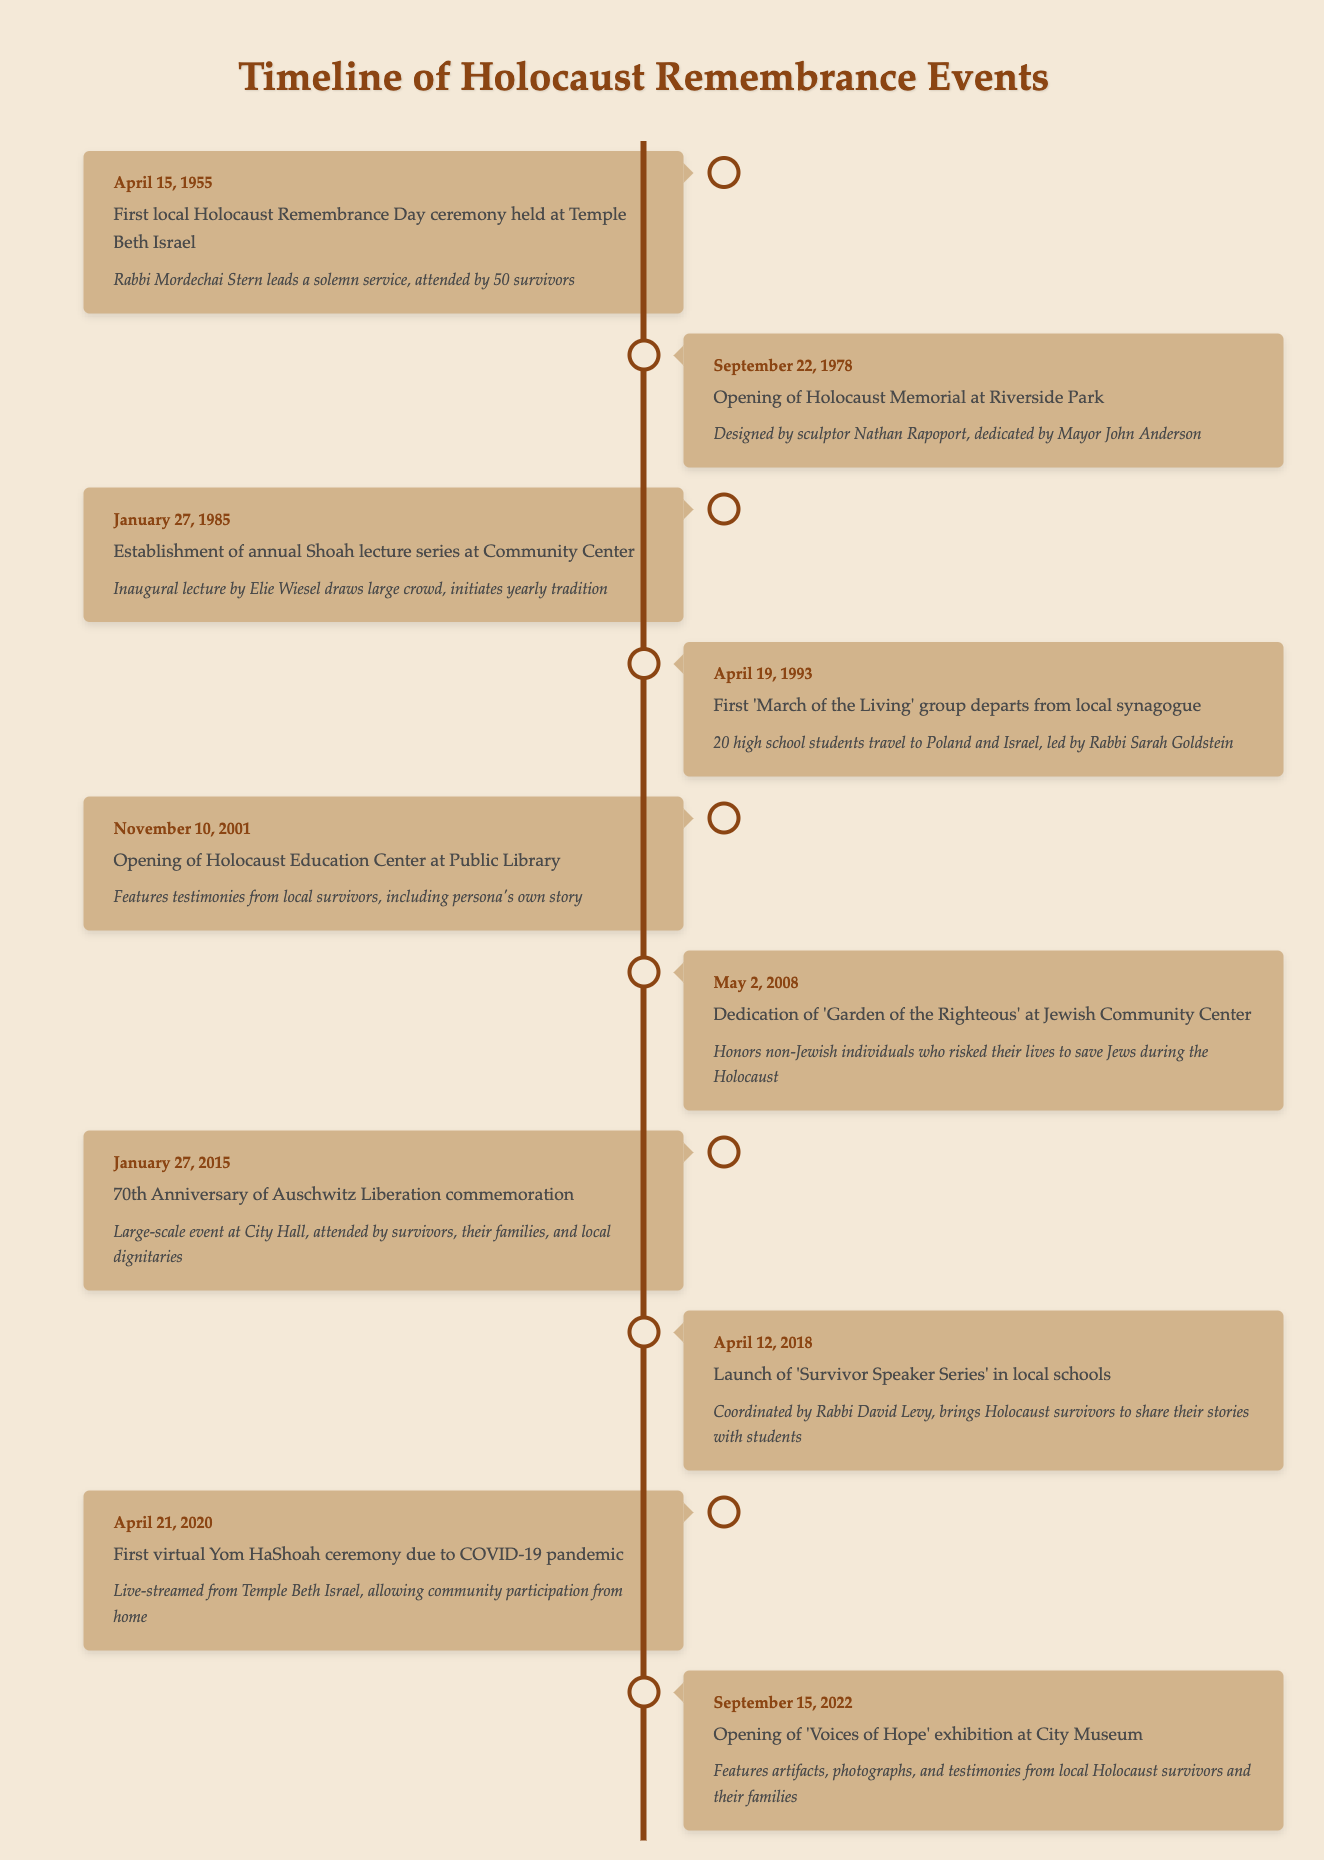What date was the first local Holocaust Remembrance Day ceremony held? According to the timeline, the first local Holocaust Remembrance Day ceremony was held on April 15, 1955. This information is directly visible under the first event listed.
Answer: April 15, 1955 Who led the first local Holocaust Remembrance Day ceremony? The table states that Rabbi Mordechai Stern led the first local Holocaust Remembrance Day ceremony. This detail is included in the description of the first event.
Answer: Rabbi Mordechai Stern How many years passed between the first Holocaust Memorial opening and the establishment of the annual Shoah lecture series? The first Holocaust Memorial was opened on September 22, 1978, while the annual Shoah lecture series was established on January 27, 1985. The difference in years between 1978 and 1985 is 7 years.
Answer: 7 years Was the opening of the Holocaust Education Center at the Public Library held before the dedication of the 'Garden of the Righteous'? The opening of the Holocaust Education Center occurred on November 10, 2001, and the dedication of the 'Garden of the Righteous' was on May 2, 2008. Since 2001 is before 2008, the answer is yes.
Answer: Yes How many significant events took place in the 2010s? The timeline lists three significant events in the 2010s: the 70th Anniversary of Auschwitz Liberation on January 27, 2015, the launch of the 'Survivor Speaker Series' on April 12, 2018, and the first virtual Yom HaShoah ceremony on April 21, 2020. When totaling these events, we find there are 3 events.
Answer: 3 events How many events took place before the establishment of the annual Shoah lecture series? The events that took place before the establishment of the annual Shoah lecture series on January 27, 1985, are as follows: First local Holocaust Remembrance Day ceremony in 1955 and the opening of the Holocaust Memorial in 1978. Therefore, there are 2 events.
Answer: 2 events Which event honored non-Jewish individuals who risked their lives during the Holocaust? The event that honored non-Jewish individuals is the dedication of the 'Garden of the Righteous' at the Jewish Community Center on May 2, 2008. This detail is explicitly stated in the description for that event.
Answer: Dedication of 'Garden of the Righteous' What notable individual delivered the inaugural lecture for the annual Shoah lecture series? The inaugural lecture for the annual Shoah lecture series held on January 27, 1985, was delivered by Elie Wiesel. This information is provided in the event's description.
Answer: Elie Wiesel 